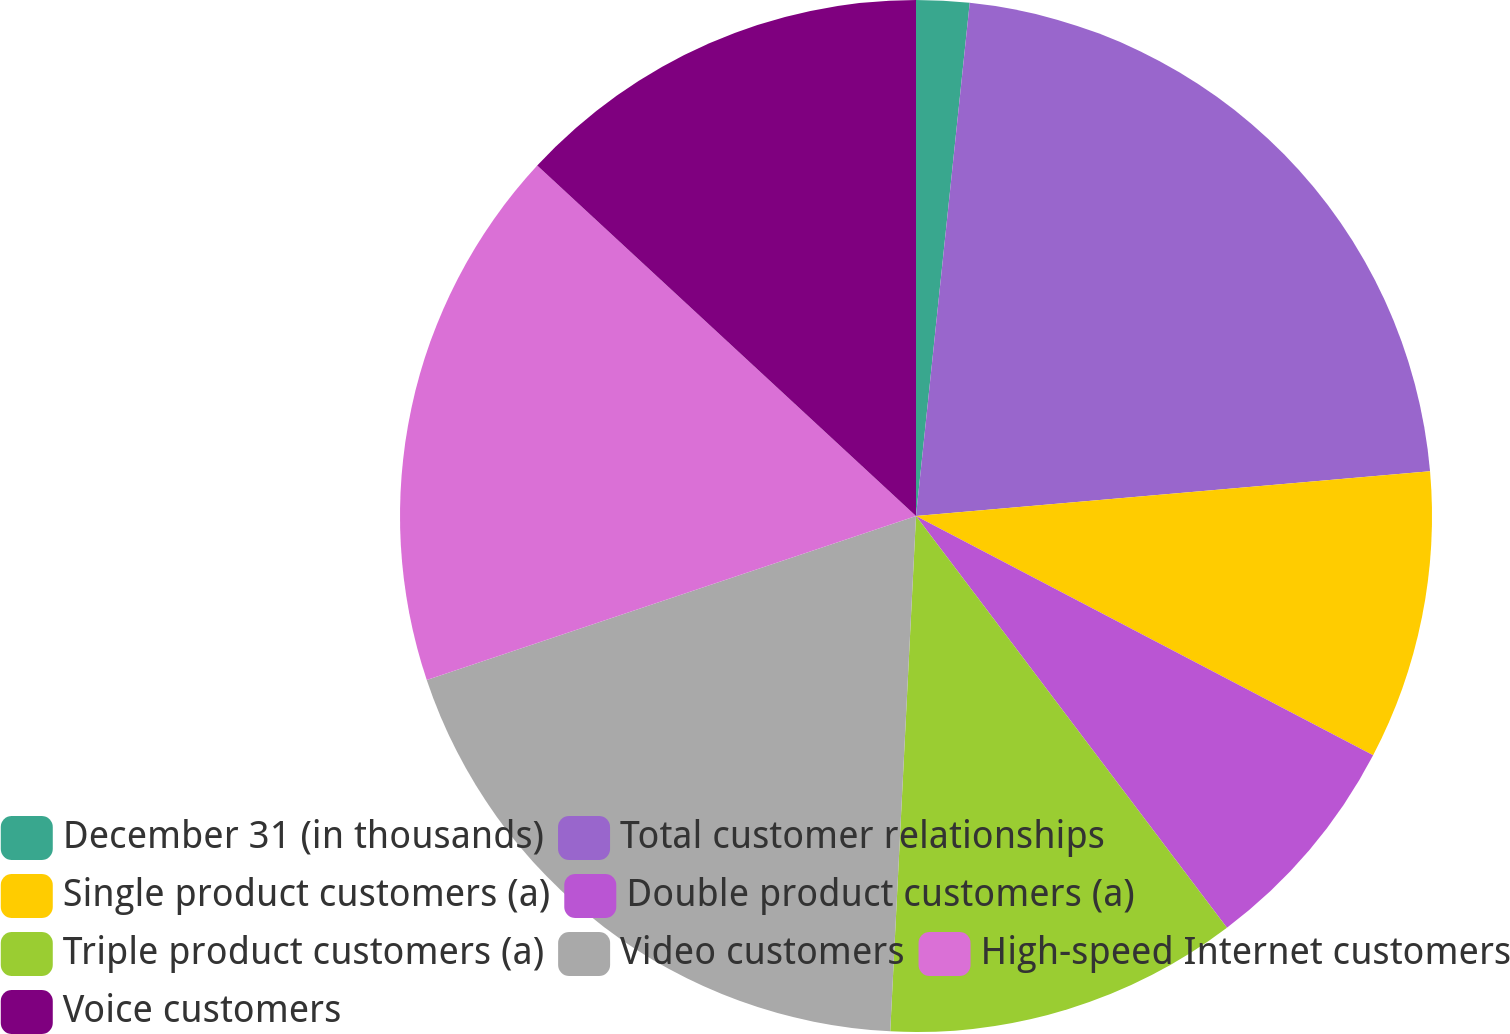Convert chart to OTSL. <chart><loc_0><loc_0><loc_500><loc_500><pie_chart><fcel>December 31 (in thousands)<fcel>Total customer relationships<fcel>Single product customers (a)<fcel>Double product customers (a)<fcel>Triple product customers (a)<fcel>Video customers<fcel>High-speed Internet customers<fcel>Voice customers<nl><fcel>1.66%<fcel>21.96%<fcel>9.06%<fcel>7.03%<fcel>11.09%<fcel>19.06%<fcel>17.03%<fcel>13.12%<nl></chart> 